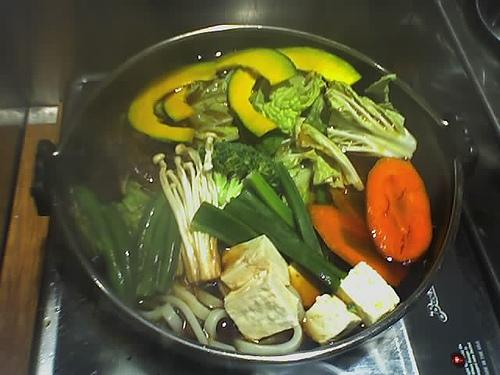What are the white blocks in the soup called?

Choices:
A) mozzarella cheese
B) cabbage
C) turnip
D) tofu tofu 